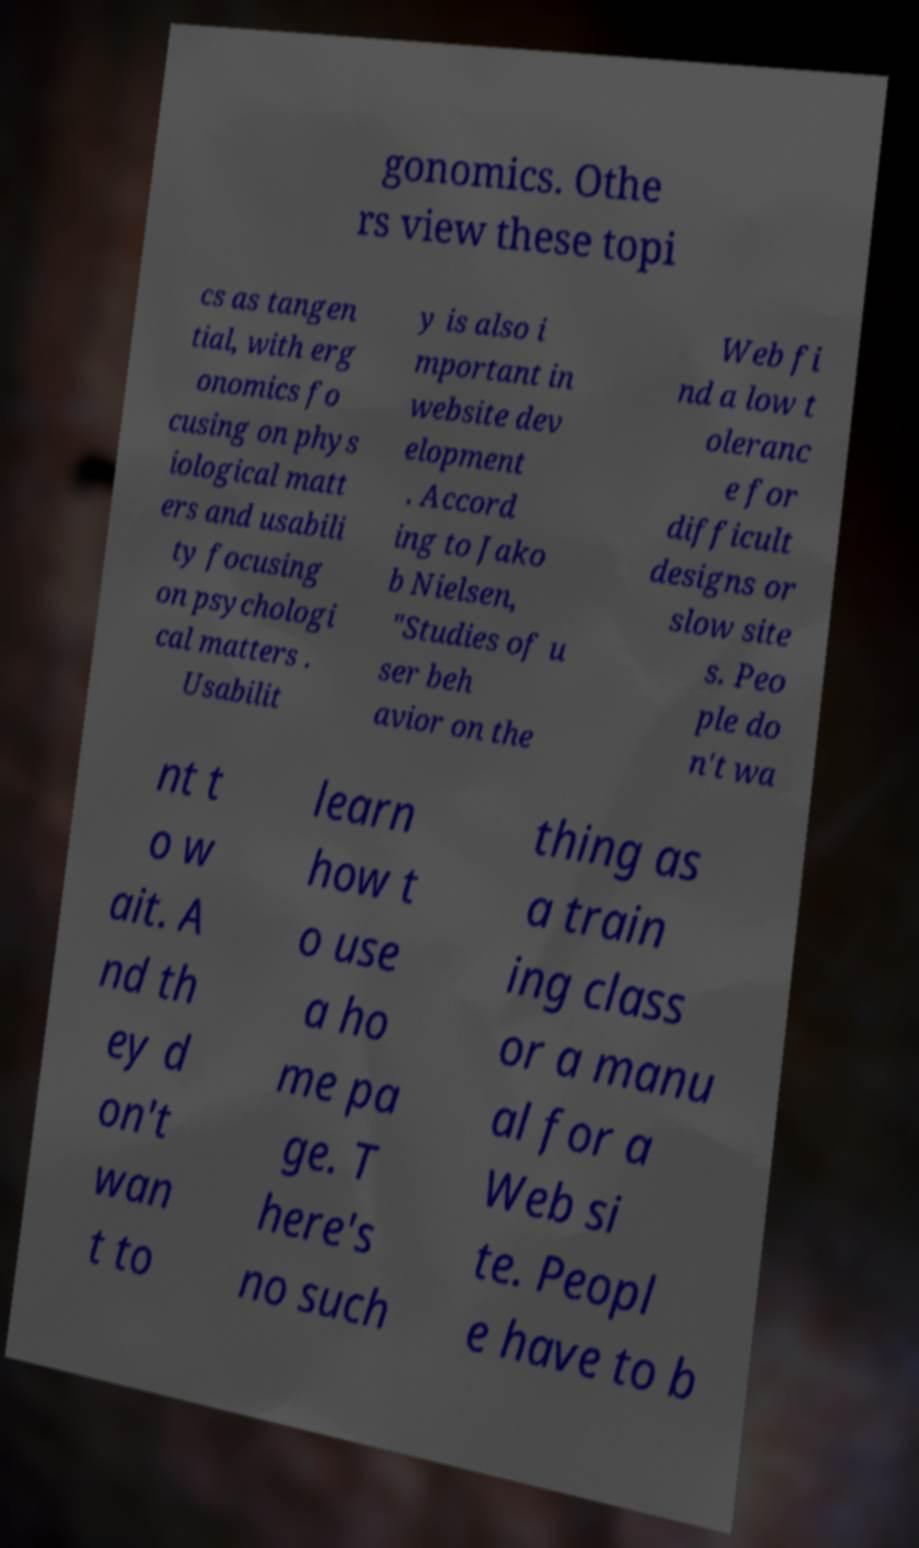Could you extract and type out the text from this image? gonomics. Othe rs view these topi cs as tangen tial, with erg onomics fo cusing on phys iological matt ers and usabili ty focusing on psychologi cal matters . Usabilit y is also i mportant in website dev elopment . Accord ing to Jako b Nielsen, "Studies of u ser beh avior on the Web fi nd a low t oleranc e for difficult designs or slow site s. Peo ple do n't wa nt t o w ait. A nd th ey d on't wan t to learn how t o use a ho me pa ge. T here's no such thing as a train ing class or a manu al for a Web si te. Peopl e have to b 